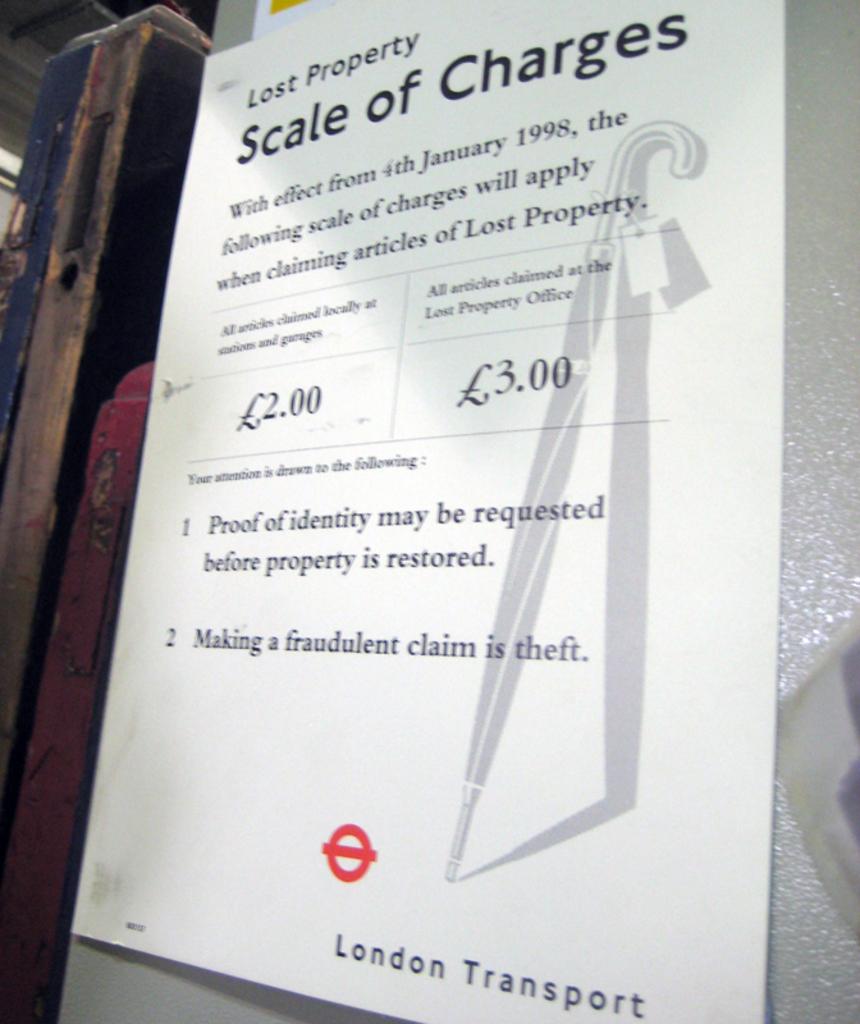Is the company on this flyer called london transport?
Your answer should be very brief. Yes. 